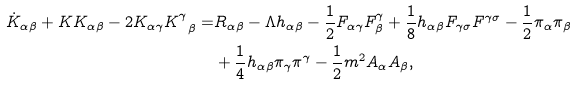Convert formula to latex. <formula><loc_0><loc_0><loc_500><loc_500>\dot { K } _ { \alpha \beta } + K K _ { \alpha \beta } - 2 K _ { \alpha \gamma } K ^ { \gamma } _ { \ \beta } = & R _ { \alpha \beta } - \Lambda h _ { \alpha \beta } - \frac { 1 } { 2 } F _ { \alpha \gamma } F _ { \beta } ^ { \gamma } + \frac { 1 } { 8 } h _ { \alpha \beta } F _ { \gamma \sigma } F ^ { \gamma \sigma } - \frac { 1 } { 2 } \pi _ { \alpha } \pi _ { \beta } \\ & + \frac { 1 } { 4 } h _ { \alpha \beta } \pi _ { \gamma } \pi ^ { \gamma } - \frac { 1 } { 2 } m ^ { 2 } A _ { \alpha } A _ { \beta } ,</formula> 